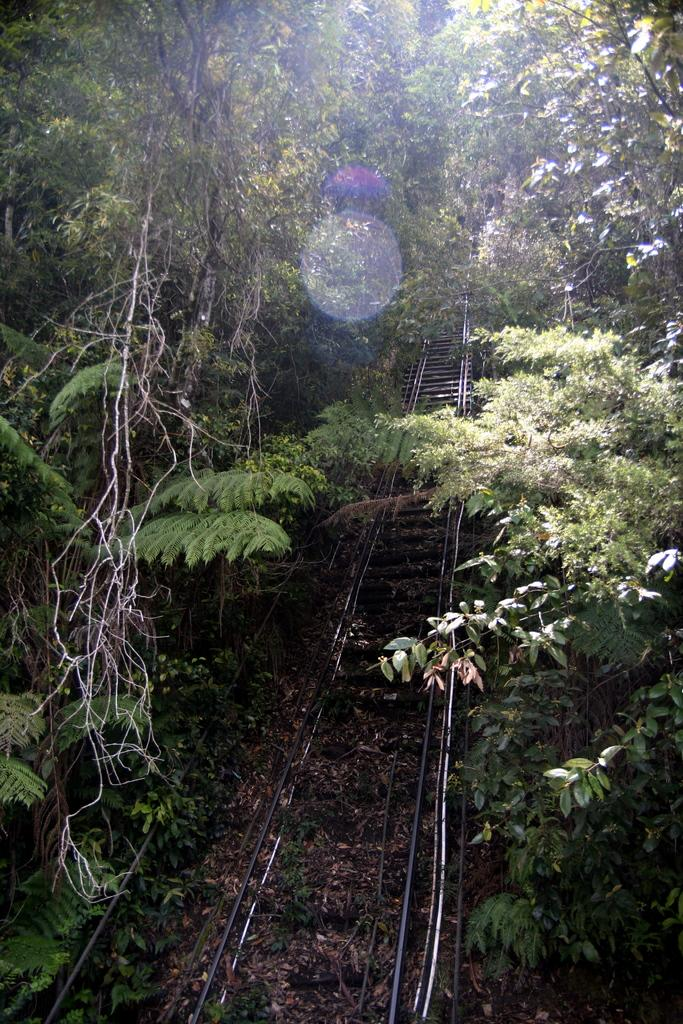What is the main subject in the center of the image? There is a railway track in the center of the image. What can be seen in the background of the image? There are trees visible in the image. Where is the family sitting and enjoying milk in the image? There is no family or milk present in the image; it only features a railway track and trees. 